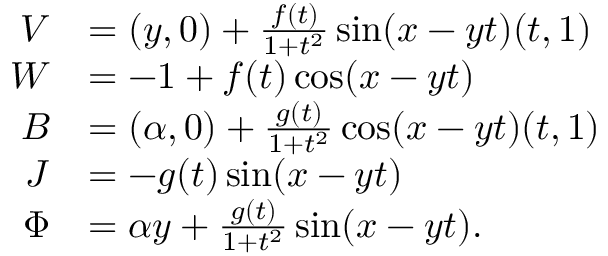<formula> <loc_0><loc_0><loc_500><loc_500>\begin{array} { r l } { V } & { = ( y , 0 ) + \frac { f ( t ) } { 1 + t ^ { 2 } } \sin ( x - y t ) ( t , 1 ) } \\ { W } & { = - 1 + f ( t ) \cos ( x - y t ) } \\ { B } & { = ( \alpha , 0 ) + \frac { g ( t ) } { 1 + t ^ { 2 } } \cos ( x - y t ) ( t , 1 ) } \\ { J } & { = - g ( t ) \sin ( x - y t ) } \\ { \Phi } & { = \alpha y + \frac { g ( t ) } { 1 + t ^ { 2 } } \sin ( x - y t ) . } \end{array}</formula> 